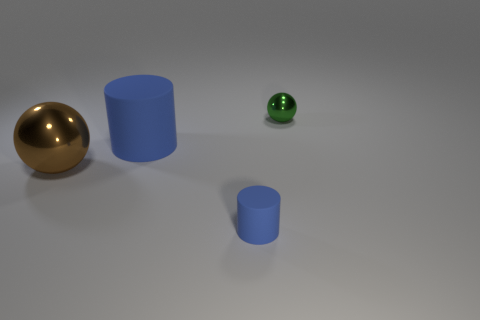What materials appear to be depicted in the objects shown? The materials represented seem to include a glossy metallic surface on the sphere, a matte rubber texture on the small green cylinder, and a solid, possibly plastic finish on the blue cylinders. 